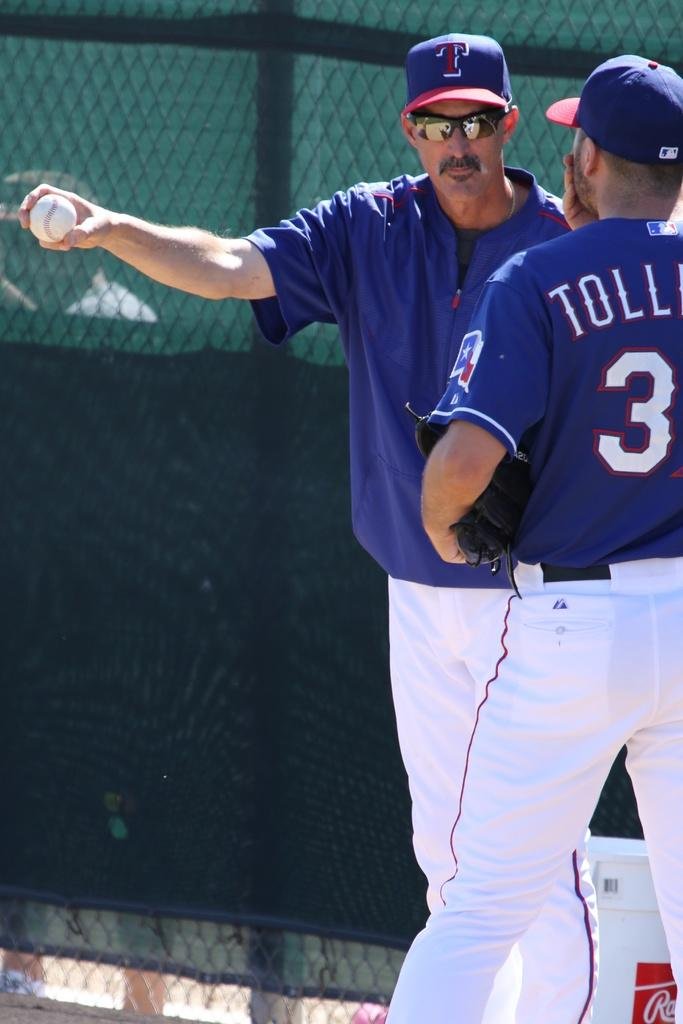<image>
Render a clear and concise summary of the photo. A baseball player in blue and white uniform talks with his coach, who is wearing a hat with a red "T". 